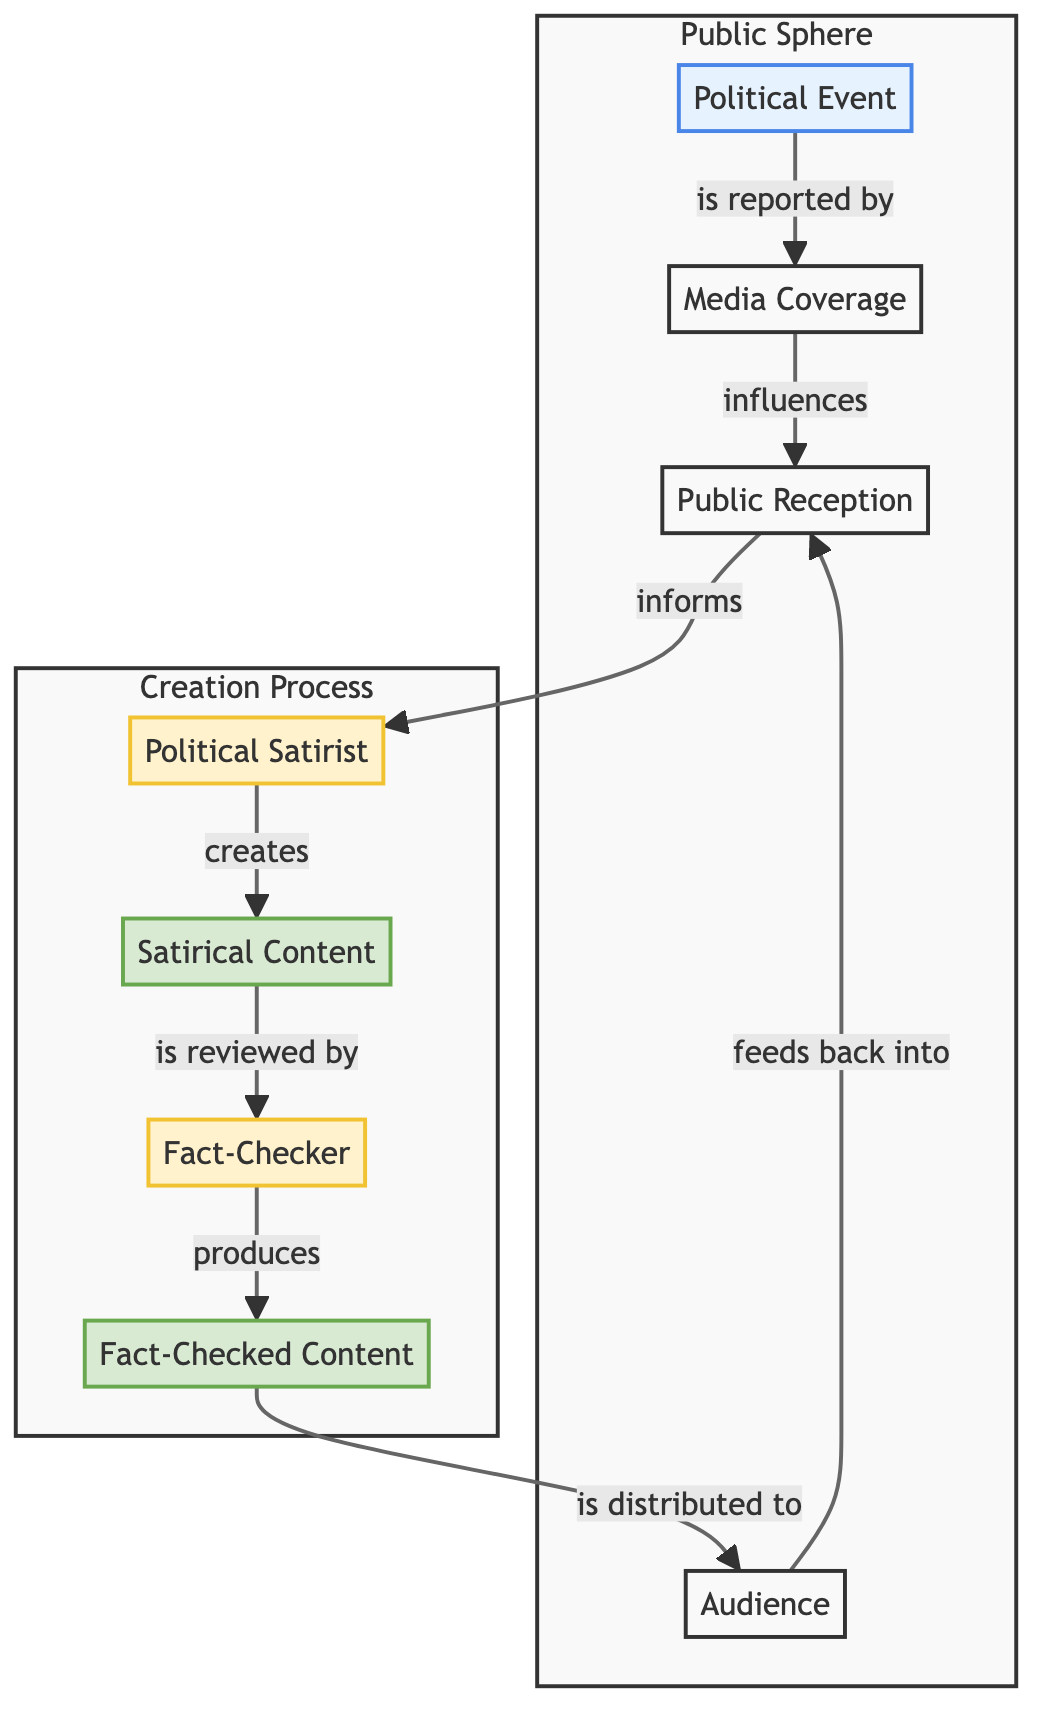What is the first node in the flow? The diagram shows that the first node in the flow is “Political Event.” This can be identified as it is positioned at the top of the flowchart and initiates the sequence.
Answer: Political Event Who is responsible for creating the satirical content? The diagram indicates that the “Political Satirist” is the one who creates the “Satirical Content.” This relationship is explicitly shown as an arrow pointing from the satirist to the content they create.
Answer: Political Satirist What influences public reception? According to the diagram, “Media Coverage” influences “Public Reception.” This is shown by a directed arrow between these two nodes indicating a flow of influence.
Answer: Media Coverage What is the relationship between fact-checkers and the content they produce? The diagram shows that the “Fact Checker” reviews “Satirical Content” and produces “Fact-Checked Content.” The flow indicates that the fact-checker is directly involved in this process.
Answer: produces How many nodes are in the Public Sphere subgraph? The Public Sphere subgraph includes four nodes: “Political Event,” “Media Coverage,” “Public Reception,” and “Audience.” By counting the nodes in this subgraph, the total is determined to be four.
Answer: 4 What does the audience feed back into? The diagram illustrates that the “Audience” feeds back into “Public Reception.” This cyclic relationship shows that the audience’s reaction can influence public perception again.
Answer: Public Reception What is the ultimate output of the fact-checking process? From the diagram, the “Fact-Checked Content” is the outcome of the fact-checking process, created after the satirical content is reviewed by the fact checker.
Answer: Fact-Checked Content What role does the political satirist play in this diagram? The “Political Satirist” acts as a creator of the “Satirical Content.” This relationship highlights the satirist’s role in producing commentary based on political events.
Answer: creates How is the media coverage connected to public reception? The diagram shows an arrow from “Media Coverage” to “Public Reception,” indicating that the coverage provided by media outlets has a direct impact on how the public receives information.
Answer: influences 